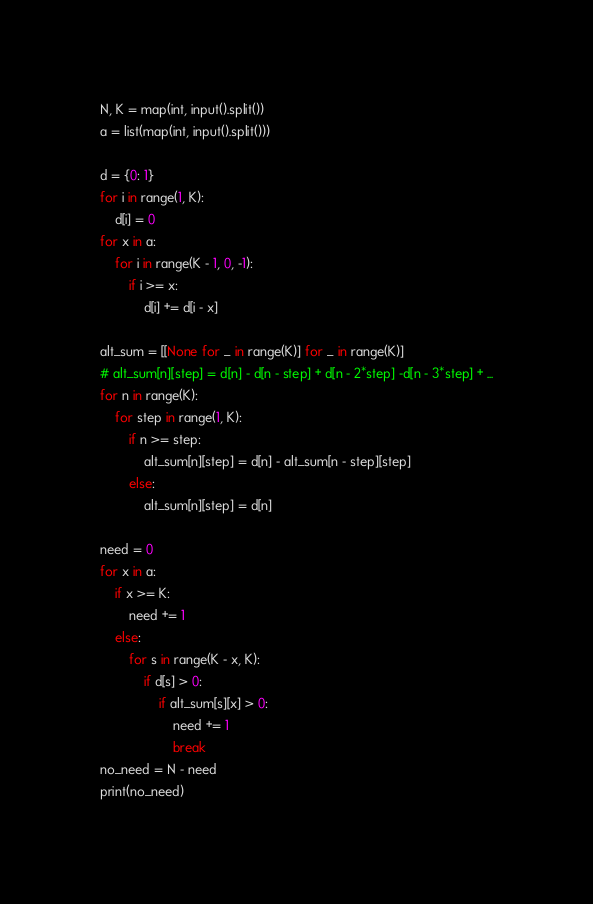<code> <loc_0><loc_0><loc_500><loc_500><_Python_>N, K = map(int, input().split())
a = list(map(int, input().split()))

d = {0: 1}
for i in range(1, K):
    d[i] = 0
for x in a:
    for i in range(K - 1, 0, -1):
        if i >= x:
            d[i] += d[i - x]

alt_sum = [[None for _ in range(K)] for _ in range(K)]
# alt_sum[n][step] = d[n] - d[n - step] + d[n - 2*step] -d[n - 3*step] + ...
for n in range(K):
    for step in range(1, K):
        if n >= step:
            alt_sum[n][step] = d[n] - alt_sum[n - step][step]
        else:
            alt_sum[n][step] = d[n]

need = 0
for x in a:
    if x >= K:
        need += 1
    else:
        for s in range(K - x, K):
            if d[s] > 0:
                if alt_sum[s][x] > 0:
                    need += 1
                    break
no_need = N - need
print(no_need)</code> 